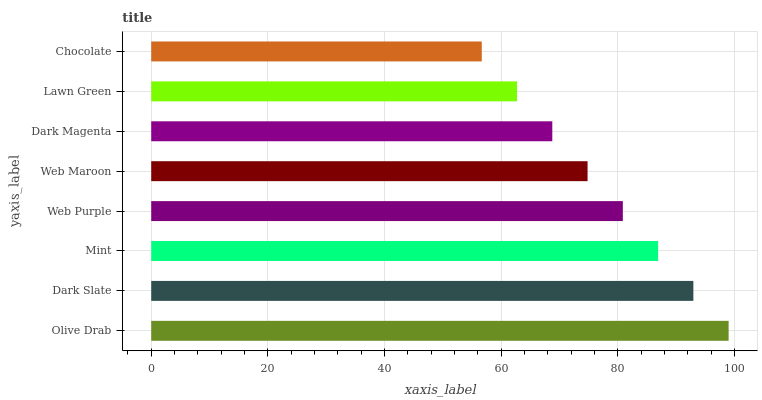Is Chocolate the minimum?
Answer yes or no. Yes. Is Olive Drab the maximum?
Answer yes or no. Yes. Is Dark Slate the minimum?
Answer yes or no. No. Is Dark Slate the maximum?
Answer yes or no. No. Is Olive Drab greater than Dark Slate?
Answer yes or no. Yes. Is Dark Slate less than Olive Drab?
Answer yes or no. Yes. Is Dark Slate greater than Olive Drab?
Answer yes or no. No. Is Olive Drab less than Dark Slate?
Answer yes or no. No. Is Web Purple the high median?
Answer yes or no. Yes. Is Web Maroon the low median?
Answer yes or no. Yes. Is Dark Magenta the high median?
Answer yes or no. No. Is Dark Magenta the low median?
Answer yes or no. No. 